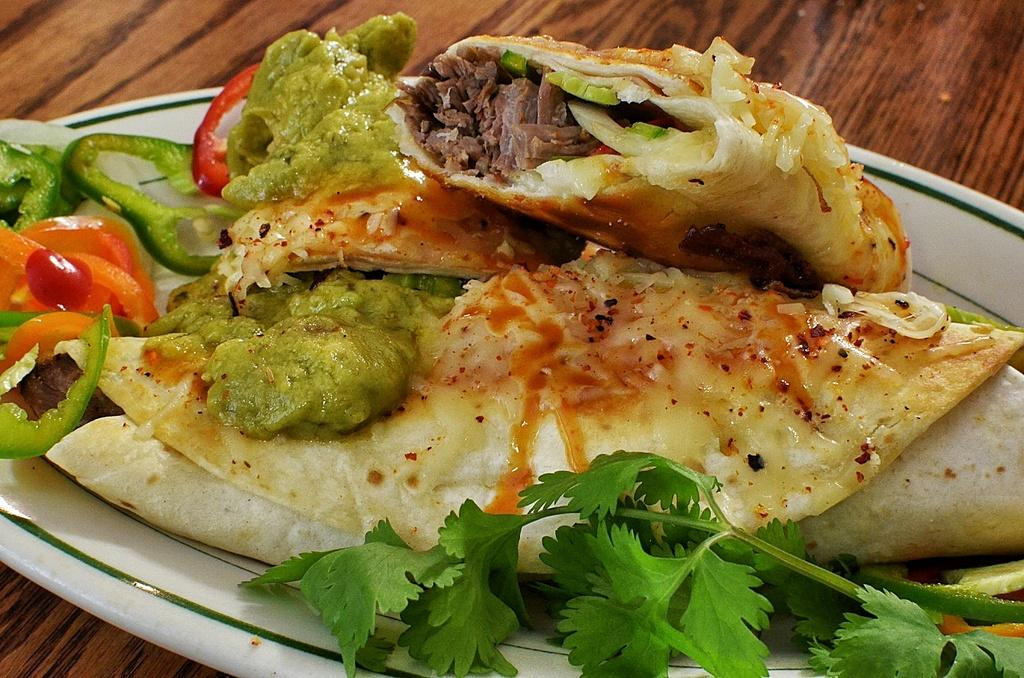What is the main piece of furniture in the image? There is a table in the image. What is placed on the table? There is a plate on the table. What type of food is on the plate? There are coriander leaves, two wraps, sauce, capsicum slices, and carrot slices on the plate. Can you see a pig supporting the plate in the image? There is no pig present in the image, and the plate is not being supported by any animal. What shape is the table in the image? The shape of the table is not mentioned in the provided facts, so we cannot determine its shape from the image. 